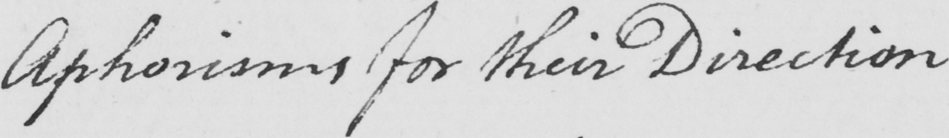Can you read and transcribe this handwriting? Aphorisms for their Direction 